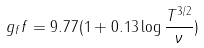Convert formula to latex. <formula><loc_0><loc_0><loc_500><loc_500>g _ { f } f = 9 . 7 7 ( 1 + 0 . 1 3 \log { \frac { T ^ { 3 / 2 } } { \nu } } )</formula> 